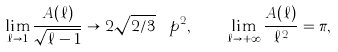<formula> <loc_0><loc_0><loc_500><loc_500>\lim _ { \ell \to 1 } \frac { A ( \ell ) } { \sqrt { \ell - 1 } } \to 2 \sqrt { 2 / 3 } \, \ p ^ { 2 } , \quad \lim _ { \ell \to + \infty } \frac { A ( \ell ) } { \ell ^ { 2 } } = \pi ,</formula> 